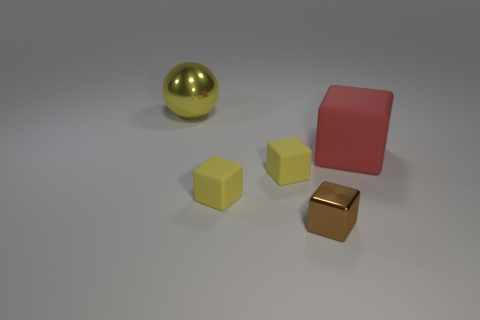Subtract all shiny blocks. How many blocks are left? 3 Add 2 brown shiny things. How many objects exist? 7 Subtract all red cubes. How many cubes are left? 3 Subtract all cubes. How many objects are left? 1 Subtract 1 spheres. How many spheres are left? 0 Add 3 large yellow metal things. How many large yellow metal things exist? 4 Subtract 0 blue blocks. How many objects are left? 5 Subtract all yellow blocks. Subtract all purple cylinders. How many blocks are left? 2 Subtract all purple spheres. How many green cubes are left? 0 Subtract all large yellow metal balls. Subtract all shiny spheres. How many objects are left? 3 